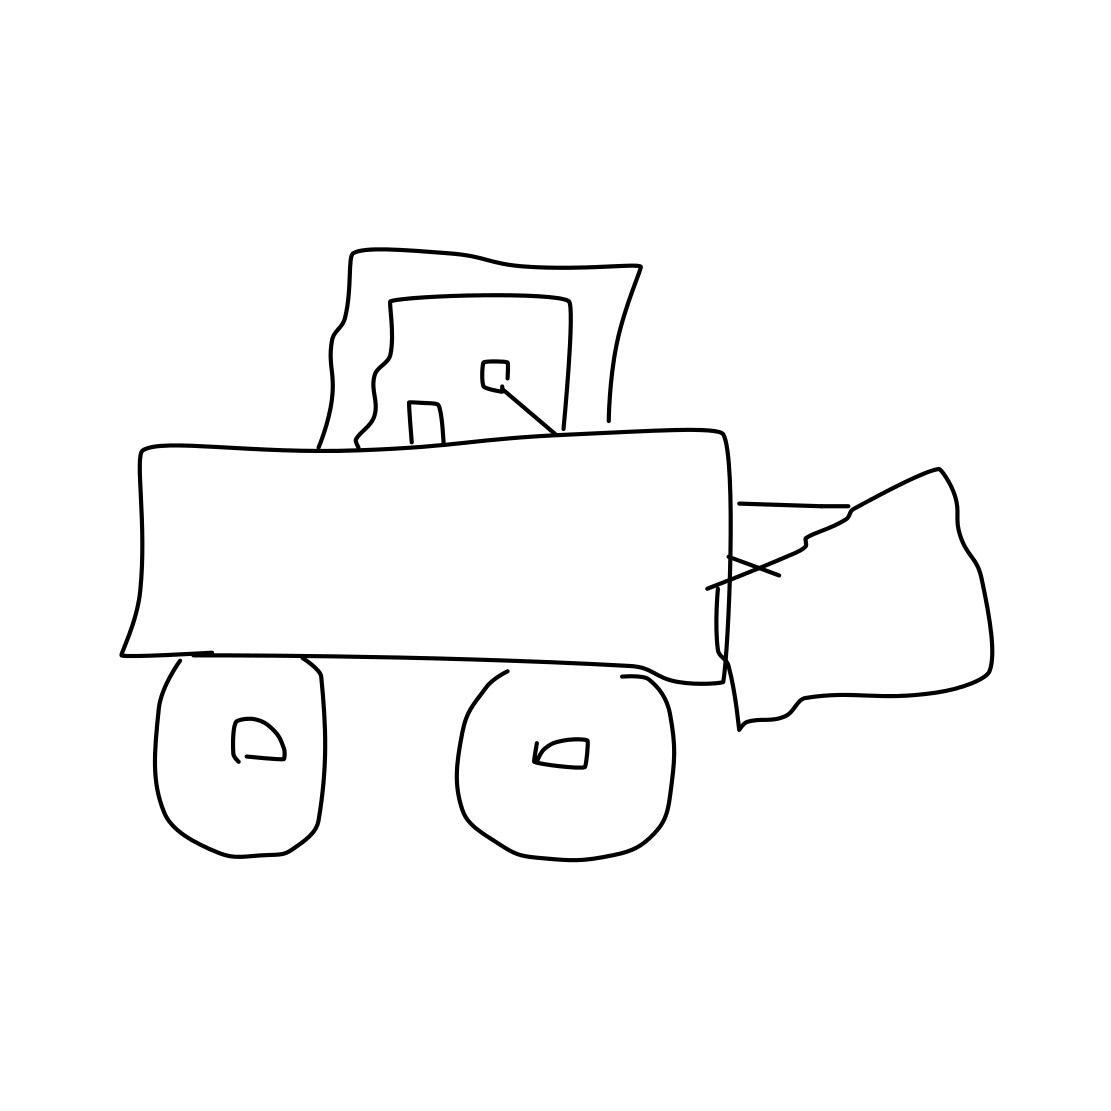Is this a nose in the image? No 